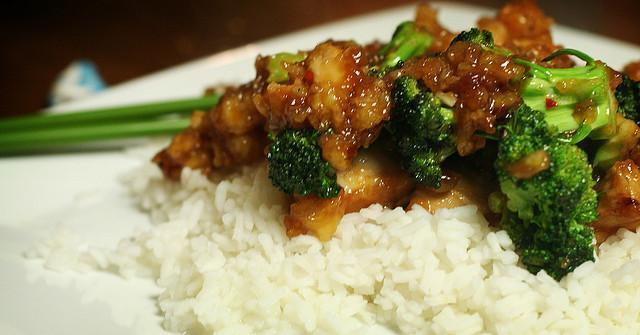How many broccolis are there?
Give a very brief answer. 4. 